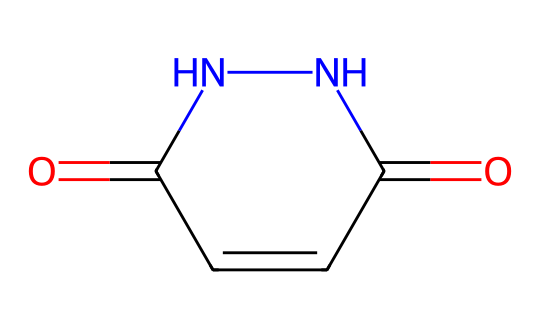What is the molecular formula of maleic hydrazide? By analyzing the provided SMILES representation, we can identify the constituent atoms: there are 4 carbons (C), 4 hydrogens (H), 2 nitrogens (N), and 2 oxygens (O). This leads to the molecular formula C4H4N2O2.
Answer: C4H4N2O2 How many nitrogen atoms are in maleic hydrazide? In the SMILES representation, 'NN' indicates the presence of two nitrogen atoms. Thus, there are 2 nitrogen atoms in the structure.
Answer: 2 What type of functional groups are present in maleic hydrazide? Looking at the structure, we can identify carbonyl groups (C=O) and an amine group (the -NN part). As a result, maleic hydrazide features both carbonyl and hydrazine functional groups.
Answer: carbonyl and hydrazine How does the structure of maleic hydrazide contribute to its function as a plant growth regulator? The carbonyl groups in maleic hydrazide play a critical role in affecting plant metabolism, as they are typically involved in reactions that influence growth regulation. The hydrazine moiety can also affect the activity and interaction of this compound with plant hormones. Overall, the combination fosters its role in growth regulation.
Answer: affects plant metabolism What is the total number of double bonds in the structure of maleic hydrazide? Examining the structure derived from the SMILES, we note that there are two double bonds present: one in the carbon-carbon (C=C) and two in the carbonyl functions (C=O). Therefore, the total number of double bonds is 3.
Answer: 3 How is maleic hydrazide classified in terms of its chemical function? . Given the structure and its application as a growth regulator in agriculture, maleic hydrazide is classified as a growth retardant, which means it slows down plant growth by inhibiting cell division and elongation.
Answer: growth retardant 